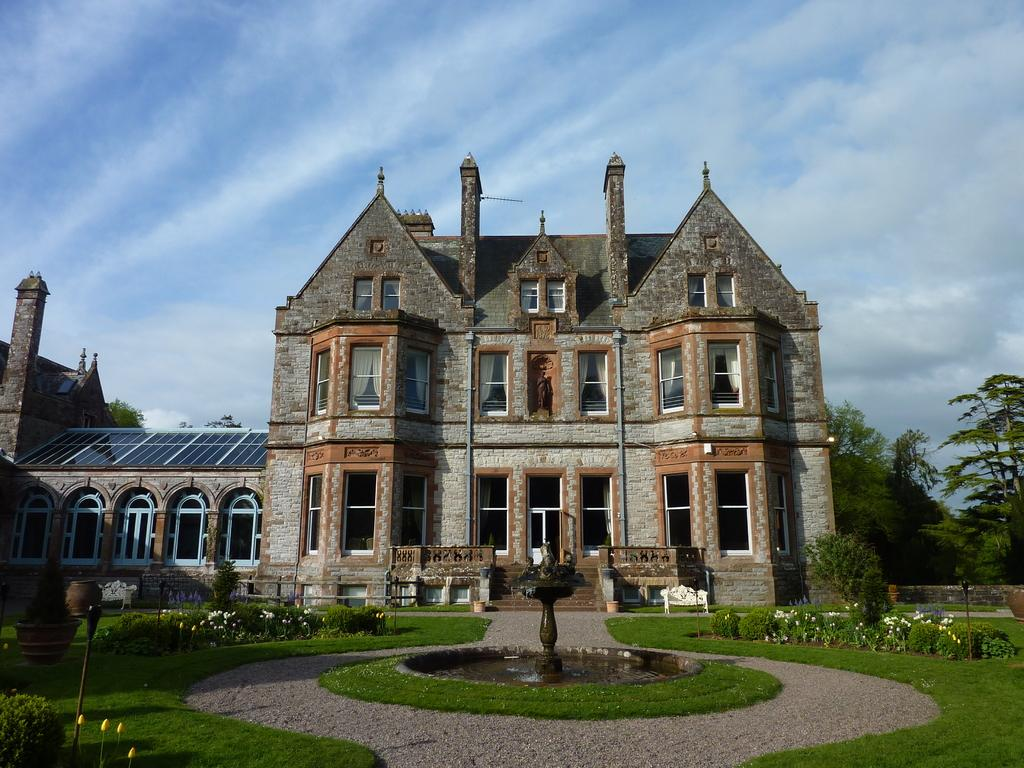What can be seen in the foreground of the image? In the foreground of the image, there are flower plants, a grassland, and a fountain. What is visible in the background of the image? In the background of the image, there are houses, benches, trees, and the sky. Can you describe the vegetation in the foreground of the image? The vegetation in the foreground includes flower plants and a grassland. What type of structures can be seen in the background of the image? In the background of the image, there are houses and benches. What natural elements are visible in the background of the image? In the background of the image, there are trees and the sky. What hobbies are the giraffes engaged in while sitting on the benches in the background of the image? There are no giraffes present in the image, so it is not possible to determine their hobbies or activities. How does the mind of the fountain in the foreground of the image work? The fountain in the image is not a living being with a mind, so it does not have a mind or thoughts. 